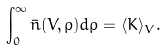<formula> <loc_0><loc_0><loc_500><loc_500>\int _ { 0 } ^ { \infty } \bar { n } ( V , \rho ) d \rho = \langle K \rangle _ { V } .</formula> 